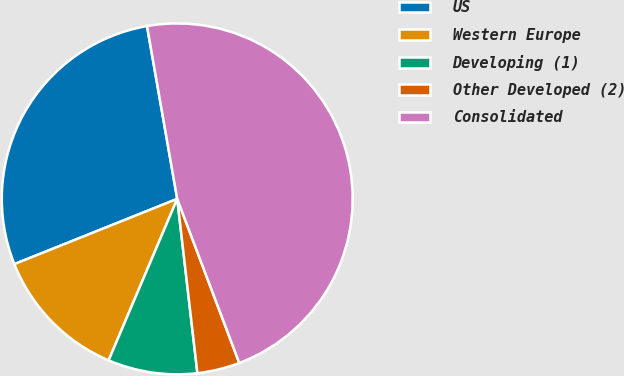<chart> <loc_0><loc_0><loc_500><loc_500><pie_chart><fcel>US<fcel>Western Europe<fcel>Developing (1)<fcel>Other Developed (2)<fcel>Consolidated<nl><fcel>28.31%<fcel>12.54%<fcel>8.23%<fcel>3.92%<fcel>47.0%<nl></chart> 